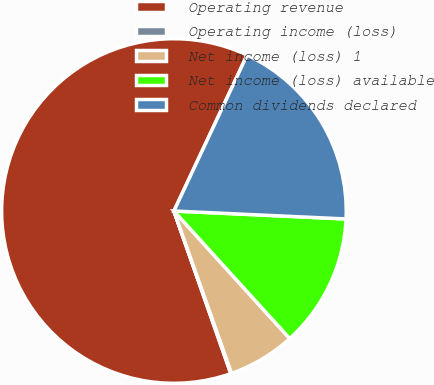Convert chart to OTSL. <chart><loc_0><loc_0><loc_500><loc_500><pie_chart><fcel>Operating revenue<fcel>Operating income (loss)<fcel>Net income (loss) 1<fcel>Net income (loss) available<fcel>Common dividends declared<nl><fcel>62.33%<fcel>0.08%<fcel>6.3%<fcel>12.53%<fcel>18.75%<nl></chart> 